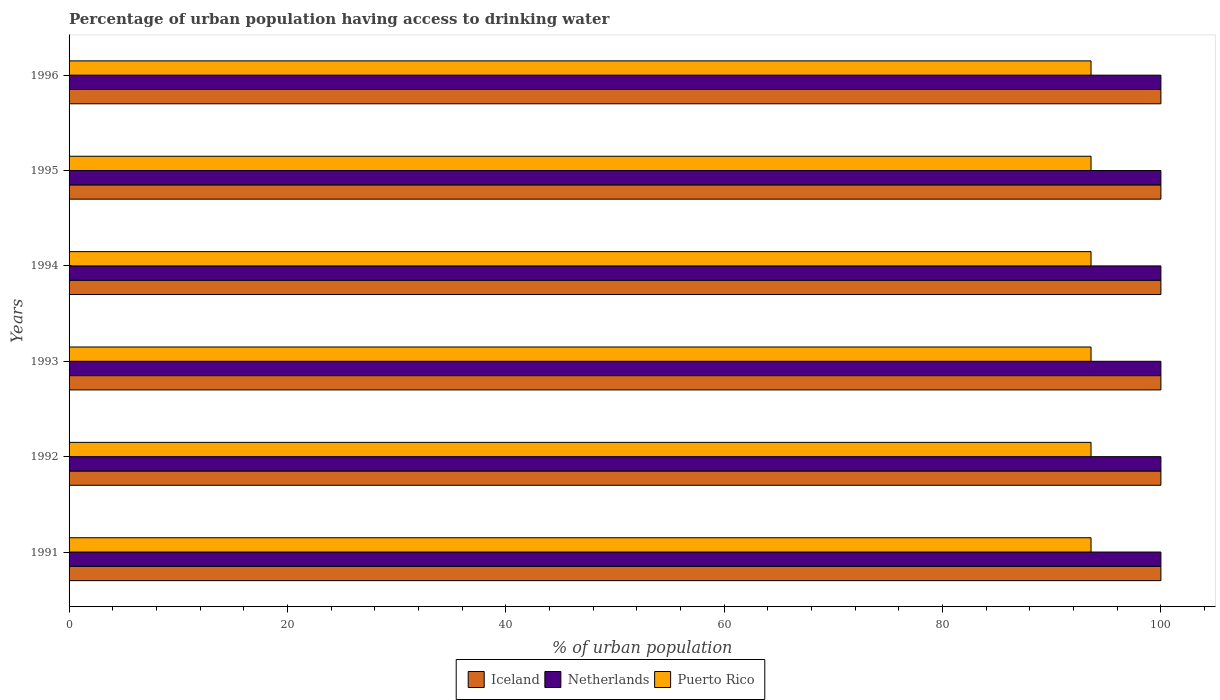How many different coloured bars are there?
Your response must be concise. 3. How many groups of bars are there?
Your answer should be very brief. 6. Are the number of bars per tick equal to the number of legend labels?
Keep it short and to the point. Yes. Are the number of bars on each tick of the Y-axis equal?
Offer a very short reply. Yes. How many bars are there on the 1st tick from the bottom?
Make the answer very short. 3. What is the label of the 4th group of bars from the top?
Your response must be concise. 1993. In how many cases, is the number of bars for a given year not equal to the number of legend labels?
Your answer should be compact. 0. What is the percentage of urban population having access to drinking water in Iceland in 1993?
Your answer should be very brief. 100. Across all years, what is the maximum percentage of urban population having access to drinking water in Iceland?
Provide a short and direct response. 100. Across all years, what is the minimum percentage of urban population having access to drinking water in Puerto Rico?
Make the answer very short. 93.6. What is the total percentage of urban population having access to drinking water in Netherlands in the graph?
Give a very brief answer. 600. What is the difference between the percentage of urban population having access to drinking water in Netherlands in 1992 and that in 1993?
Give a very brief answer. 0. What is the difference between the percentage of urban population having access to drinking water in Iceland in 1994 and the percentage of urban population having access to drinking water in Netherlands in 1993?
Make the answer very short. 0. What is the average percentage of urban population having access to drinking water in Iceland per year?
Give a very brief answer. 100. In the year 1991, what is the difference between the percentage of urban population having access to drinking water in Iceland and percentage of urban population having access to drinking water in Netherlands?
Make the answer very short. 0. Is the difference between the percentage of urban population having access to drinking water in Iceland in 1991 and 1993 greater than the difference between the percentage of urban population having access to drinking water in Netherlands in 1991 and 1993?
Your answer should be compact. No. What does the 3rd bar from the top in 1996 represents?
Offer a terse response. Iceland. What does the 2nd bar from the bottom in 1995 represents?
Your response must be concise. Netherlands. Is it the case that in every year, the sum of the percentage of urban population having access to drinking water in Puerto Rico and percentage of urban population having access to drinking water in Netherlands is greater than the percentage of urban population having access to drinking water in Iceland?
Ensure brevity in your answer.  Yes. How many years are there in the graph?
Ensure brevity in your answer.  6. What is the difference between two consecutive major ticks on the X-axis?
Give a very brief answer. 20. Does the graph contain grids?
Ensure brevity in your answer.  No. Where does the legend appear in the graph?
Provide a succinct answer. Bottom center. What is the title of the graph?
Ensure brevity in your answer.  Percentage of urban population having access to drinking water. Does "Nicaragua" appear as one of the legend labels in the graph?
Make the answer very short. No. What is the label or title of the X-axis?
Offer a very short reply. % of urban population. What is the % of urban population in Puerto Rico in 1991?
Offer a terse response. 93.6. What is the % of urban population of Iceland in 1992?
Ensure brevity in your answer.  100. What is the % of urban population of Netherlands in 1992?
Provide a short and direct response. 100. What is the % of urban population of Puerto Rico in 1992?
Your answer should be very brief. 93.6. What is the % of urban population in Netherlands in 1993?
Ensure brevity in your answer.  100. What is the % of urban population of Puerto Rico in 1993?
Make the answer very short. 93.6. What is the % of urban population in Iceland in 1994?
Provide a short and direct response. 100. What is the % of urban population in Puerto Rico in 1994?
Keep it short and to the point. 93.6. What is the % of urban population in Iceland in 1995?
Offer a terse response. 100. What is the % of urban population of Puerto Rico in 1995?
Your answer should be compact. 93.6. What is the % of urban population of Iceland in 1996?
Give a very brief answer. 100. What is the % of urban population of Netherlands in 1996?
Ensure brevity in your answer.  100. What is the % of urban population of Puerto Rico in 1996?
Your answer should be compact. 93.6. Across all years, what is the maximum % of urban population in Netherlands?
Keep it short and to the point. 100. Across all years, what is the maximum % of urban population in Puerto Rico?
Give a very brief answer. 93.6. Across all years, what is the minimum % of urban population of Iceland?
Offer a very short reply. 100. Across all years, what is the minimum % of urban population in Netherlands?
Give a very brief answer. 100. Across all years, what is the minimum % of urban population in Puerto Rico?
Offer a terse response. 93.6. What is the total % of urban population in Iceland in the graph?
Provide a succinct answer. 600. What is the total % of urban population of Netherlands in the graph?
Keep it short and to the point. 600. What is the total % of urban population in Puerto Rico in the graph?
Ensure brevity in your answer.  561.6. What is the difference between the % of urban population of Netherlands in 1991 and that in 1993?
Your response must be concise. 0. What is the difference between the % of urban population of Iceland in 1991 and that in 1994?
Keep it short and to the point. 0. What is the difference between the % of urban population in Netherlands in 1991 and that in 1994?
Ensure brevity in your answer.  0. What is the difference between the % of urban population in Puerto Rico in 1991 and that in 1994?
Provide a succinct answer. 0. What is the difference between the % of urban population in Puerto Rico in 1991 and that in 1995?
Offer a very short reply. 0. What is the difference between the % of urban population of Iceland in 1991 and that in 1996?
Your response must be concise. 0. What is the difference between the % of urban population of Netherlands in 1991 and that in 1996?
Provide a succinct answer. 0. What is the difference between the % of urban population of Iceland in 1992 and that in 1993?
Make the answer very short. 0. What is the difference between the % of urban population of Puerto Rico in 1992 and that in 1993?
Your answer should be compact. 0. What is the difference between the % of urban population in Iceland in 1992 and that in 1994?
Provide a succinct answer. 0. What is the difference between the % of urban population of Netherlands in 1992 and that in 1994?
Provide a short and direct response. 0. What is the difference between the % of urban population in Netherlands in 1992 and that in 1995?
Ensure brevity in your answer.  0. What is the difference between the % of urban population in Puerto Rico in 1992 and that in 1995?
Provide a succinct answer. 0. What is the difference between the % of urban population in Netherlands in 1992 and that in 1996?
Ensure brevity in your answer.  0. What is the difference between the % of urban population in Puerto Rico in 1992 and that in 1996?
Provide a short and direct response. 0. What is the difference between the % of urban population in Netherlands in 1993 and that in 1994?
Provide a succinct answer. 0. What is the difference between the % of urban population of Puerto Rico in 1993 and that in 1994?
Ensure brevity in your answer.  0. What is the difference between the % of urban population in Iceland in 1993 and that in 1995?
Keep it short and to the point. 0. What is the difference between the % of urban population of Puerto Rico in 1993 and that in 1995?
Your answer should be very brief. 0. What is the difference between the % of urban population in Iceland in 1993 and that in 1996?
Provide a short and direct response. 0. What is the difference between the % of urban population in Netherlands in 1993 and that in 1996?
Provide a short and direct response. 0. What is the difference between the % of urban population of Puerto Rico in 1993 and that in 1996?
Make the answer very short. 0. What is the difference between the % of urban population of Puerto Rico in 1994 and that in 1995?
Provide a succinct answer. 0. What is the difference between the % of urban population in Iceland in 1994 and that in 1996?
Your answer should be very brief. 0. What is the difference between the % of urban population of Netherlands in 1995 and that in 1996?
Provide a short and direct response. 0. What is the difference between the % of urban population of Iceland in 1991 and the % of urban population of Netherlands in 1992?
Provide a succinct answer. 0. What is the difference between the % of urban population in Netherlands in 1991 and the % of urban population in Puerto Rico in 1992?
Offer a terse response. 6.4. What is the difference between the % of urban population in Iceland in 1991 and the % of urban population in Puerto Rico in 1994?
Offer a terse response. 6.4. What is the difference between the % of urban population in Iceland in 1991 and the % of urban population in Puerto Rico in 1995?
Keep it short and to the point. 6.4. What is the difference between the % of urban population in Iceland in 1991 and the % of urban population in Puerto Rico in 1996?
Keep it short and to the point. 6.4. What is the difference between the % of urban population of Netherlands in 1991 and the % of urban population of Puerto Rico in 1996?
Keep it short and to the point. 6.4. What is the difference between the % of urban population of Iceland in 1992 and the % of urban population of Puerto Rico in 1993?
Offer a very short reply. 6.4. What is the difference between the % of urban population of Netherlands in 1992 and the % of urban population of Puerto Rico in 1993?
Your answer should be very brief. 6.4. What is the difference between the % of urban population in Iceland in 1992 and the % of urban population in Netherlands in 1995?
Your answer should be compact. 0. What is the difference between the % of urban population in Iceland in 1992 and the % of urban population in Puerto Rico in 1995?
Make the answer very short. 6.4. What is the difference between the % of urban population in Netherlands in 1992 and the % of urban population in Puerto Rico in 1995?
Give a very brief answer. 6.4. What is the difference between the % of urban population in Iceland in 1992 and the % of urban population in Netherlands in 1996?
Your answer should be very brief. 0. What is the difference between the % of urban population in Iceland in 1993 and the % of urban population in Puerto Rico in 1994?
Ensure brevity in your answer.  6.4. What is the difference between the % of urban population in Netherlands in 1993 and the % of urban population in Puerto Rico in 1994?
Give a very brief answer. 6.4. What is the difference between the % of urban population in Netherlands in 1993 and the % of urban population in Puerto Rico in 1996?
Your response must be concise. 6.4. What is the difference between the % of urban population of Iceland in 1994 and the % of urban population of Netherlands in 1995?
Your response must be concise. 0. What is the difference between the % of urban population of Netherlands in 1994 and the % of urban population of Puerto Rico in 1995?
Keep it short and to the point. 6.4. What is the difference between the % of urban population in Iceland in 1994 and the % of urban population in Netherlands in 1996?
Your answer should be compact. 0. What is the difference between the % of urban population in Iceland in 1995 and the % of urban population in Netherlands in 1996?
Keep it short and to the point. 0. What is the difference between the % of urban population of Iceland in 1995 and the % of urban population of Puerto Rico in 1996?
Give a very brief answer. 6.4. What is the difference between the % of urban population in Netherlands in 1995 and the % of urban population in Puerto Rico in 1996?
Make the answer very short. 6.4. What is the average % of urban population in Iceland per year?
Make the answer very short. 100. What is the average % of urban population of Puerto Rico per year?
Give a very brief answer. 93.6. In the year 1991, what is the difference between the % of urban population in Netherlands and % of urban population in Puerto Rico?
Give a very brief answer. 6.4. In the year 1992, what is the difference between the % of urban population in Iceland and % of urban population in Netherlands?
Offer a very short reply. 0. In the year 1992, what is the difference between the % of urban population in Netherlands and % of urban population in Puerto Rico?
Provide a short and direct response. 6.4. In the year 1993, what is the difference between the % of urban population of Iceland and % of urban population of Puerto Rico?
Give a very brief answer. 6.4. In the year 1994, what is the difference between the % of urban population of Iceland and % of urban population of Puerto Rico?
Make the answer very short. 6.4. In the year 1995, what is the difference between the % of urban population of Netherlands and % of urban population of Puerto Rico?
Ensure brevity in your answer.  6.4. In the year 1996, what is the difference between the % of urban population in Iceland and % of urban population in Netherlands?
Your answer should be compact. 0. In the year 1996, what is the difference between the % of urban population in Iceland and % of urban population in Puerto Rico?
Give a very brief answer. 6.4. In the year 1996, what is the difference between the % of urban population of Netherlands and % of urban population of Puerto Rico?
Your answer should be very brief. 6.4. What is the ratio of the % of urban population of Puerto Rico in 1991 to that in 1992?
Your answer should be very brief. 1. What is the ratio of the % of urban population of Puerto Rico in 1991 to that in 1995?
Give a very brief answer. 1. What is the ratio of the % of urban population in Netherlands in 1992 to that in 1993?
Your response must be concise. 1. What is the ratio of the % of urban population of Iceland in 1992 to that in 1994?
Your answer should be very brief. 1. What is the ratio of the % of urban population of Netherlands in 1992 to that in 1994?
Offer a very short reply. 1. What is the ratio of the % of urban population of Puerto Rico in 1992 to that in 1994?
Keep it short and to the point. 1. What is the ratio of the % of urban population of Netherlands in 1992 to that in 1996?
Your answer should be very brief. 1. What is the ratio of the % of urban population of Netherlands in 1993 to that in 1994?
Give a very brief answer. 1. What is the ratio of the % of urban population of Puerto Rico in 1993 to that in 1994?
Ensure brevity in your answer.  1. What is the ratio of the % of urban population of Netherlands in 1993 to that in 1996?
Make the answer very short. 1. What is the ratio of the % of urban population in Puerto Rico in 1994 to that in 1995?
Give a very brief answer. 1. What is the ratio of the % of urban population of Netherlands in 1994 to that in 1996?
Offer a very short reply. 1. What is the ratio of the % of urban population of Iceland in 1995 to that in 1996?
Give a very brief answer. 1. What is the ratio of the % of urban population of Netherlands in 1995 to that in 1996?
Provide a succinct answer. 1. What is the difference between the highest and the lowest % of urban population in Iceland?
Your response must be concise. 0. 